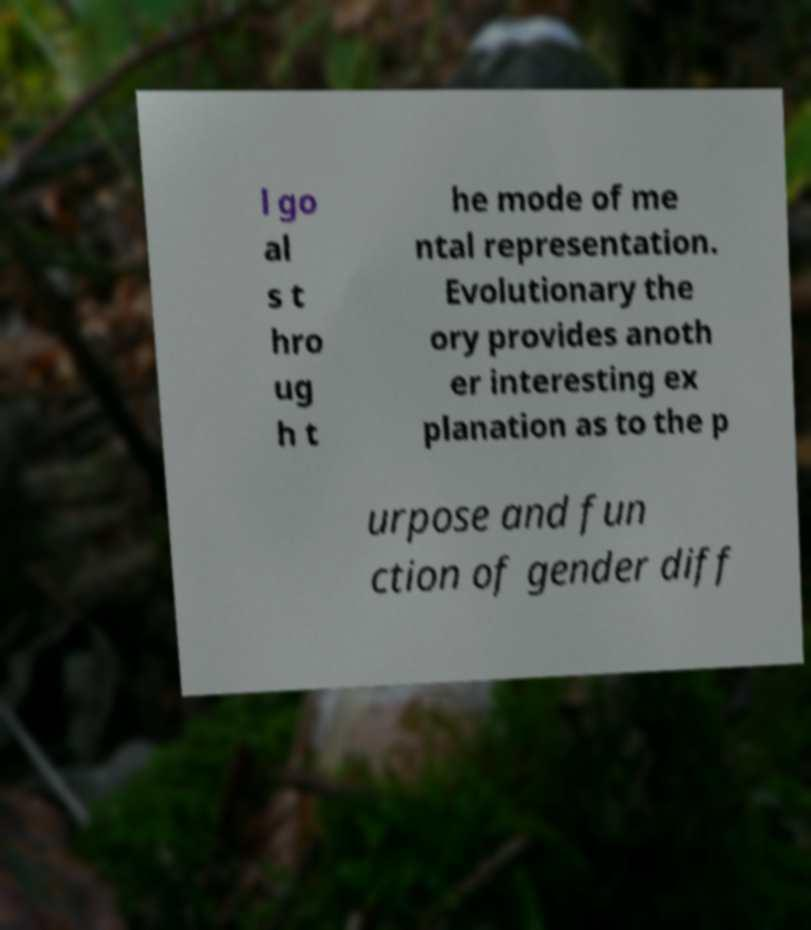What messages or text are displayed in this image? I need them in a readable, typed format. l go al s t hro ug h t he mode of me ntal representation. Evolutionary the ory provides anoth er interesting ex planation as to the p urpose and fun ction of gender diff 